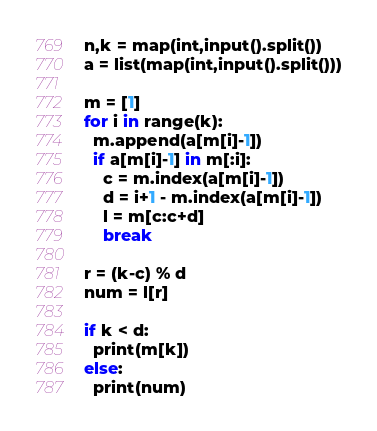<code> <loc_0><loc_0><loc_500><loc_500><_Python_>n,k = map(int,input().split())
a = list(map(int,input().split()))

m = [1]
for i in range(k):
  m.append(a[m[i]-1])
  if a[m[i]-1] in m[:i]:
    c = m.index(a[m[i]-1])
    d = i+1 - m.index(a[m[i]-1])
    l = m[c:c+d]
    break

r = (k-c) % d
num = l[r]

if k < d:
  print(m[k])
else:
  print(num)</code> 